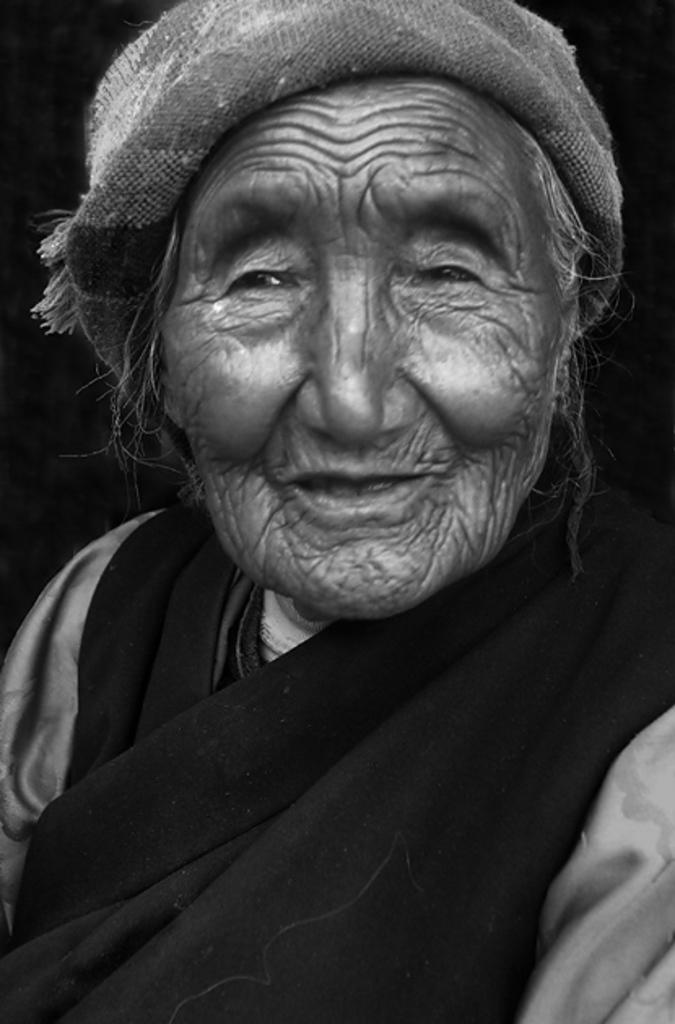Who is the main subject in the image? There is an old woman in the image. What type of amusement can be seen on the island in the image? There is no island or amusement present in the image; it features an old woman. Where is the park located in the image? There is no park present in the image; it features an old woman. 